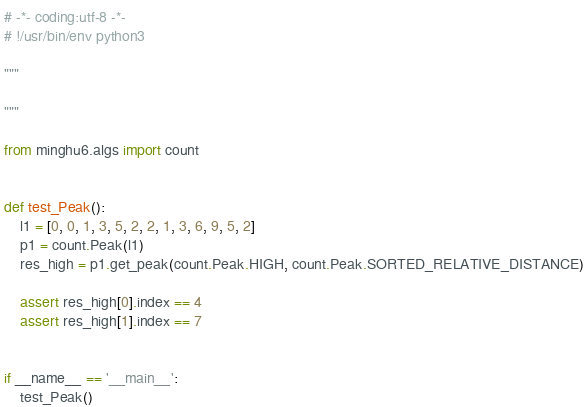Convert code to text. <code><loc_0><loc_0><loc_500><loc_500><_Python_># -*- coding:utf-8 -*-
# !/usr/bin/env python3

"""

"""

from minghu6.algs import count


def test_Peak():
    l1 = [0, 0, 1, 3, 5, 2, 2, 1, 3, 6, 9, 5, 2]
    p1 = count.Peak(l1)
    res_high = p1.get_peak(count.Peak.HIGH, count.Peak.SORTED_RELATIVE_DISTANCE)

    assert res_high[0].index == 4
    assert res_high[1].index == 7


if __name__ == '__main__':
    test_Peak()
</code> 